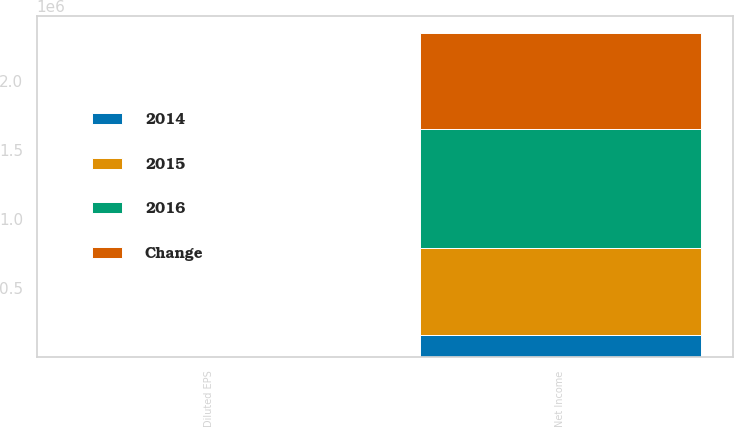Convert chart to OTSL. <chart><loc_0><loc_0><loc_500><loc_500><stacked_bar_chart><ecel><fcel>Net Income<fcel>Diluted EPS<nl><fcel>2016<fcel>861664<fcel>2.76<nl><fcel>Change<fcel>696878<fcel>2.2<nl><fcel>2015<fcel>629320<fcel>1.98<nl><fcel>2014<fcel>164786<fcel>0.56<nl></chart> 